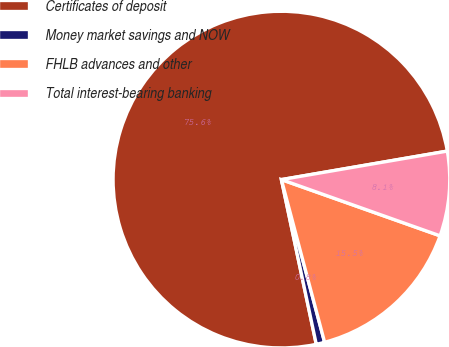Convert chart to OTSL. <chart><loc_0><loc_0><loc_500><loc_500><pie_chart><fcel>Certificates of deposit<fcel>Money market savings and NOW<fcel>FHLB advances and other<fcel>Total interest-bearing banking<nl><fcel>75.61%<fcel>0.81%<fcel>15.45%<fcel>8.13%<nl></chart> 